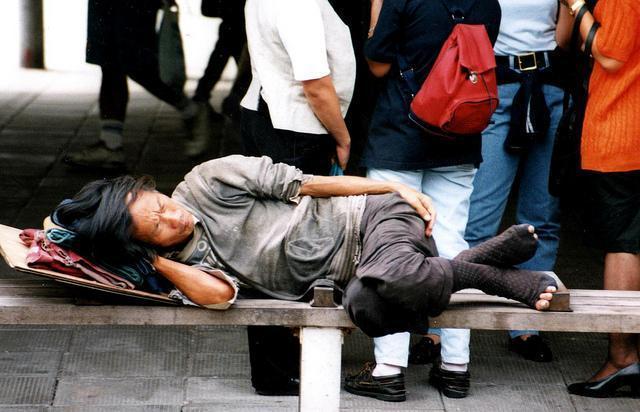How many backpacks are in the picture?
Give a very brief answer. 1. How many people are there?
Give a very brief answer. 7. 